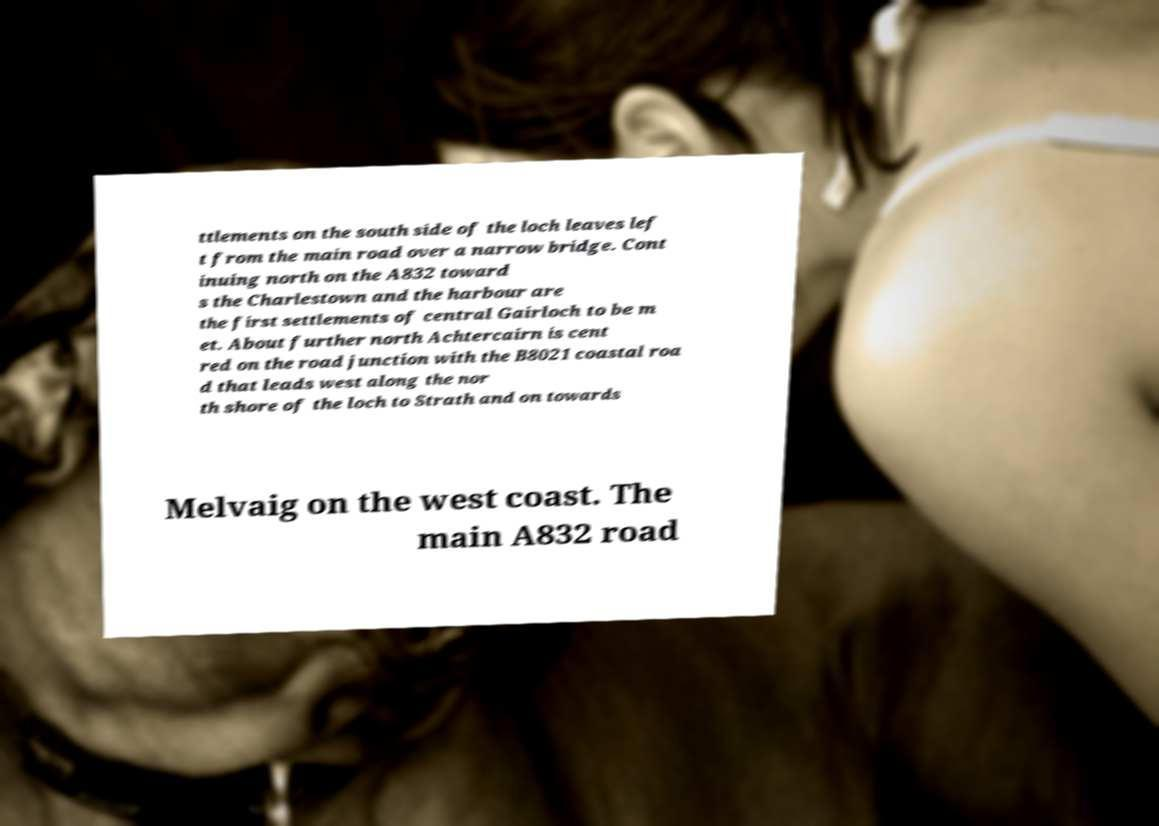For documentation purposes, I need the text within this image transcribed. Could you provide that? ttlements on the south side of the loch leaves lef t from the main road over a narrow bridge. Cont inuing north on the A832 toward s the Charlestown and the harbour are the first settlements of central Gairloch to be m et. About further north Achtercairn is cent red on the road junction with the B8021 coastal roa d that leads west along the nor th shore of the loch to Strath and on towards Melvaig on the west coast. The main A832 road 